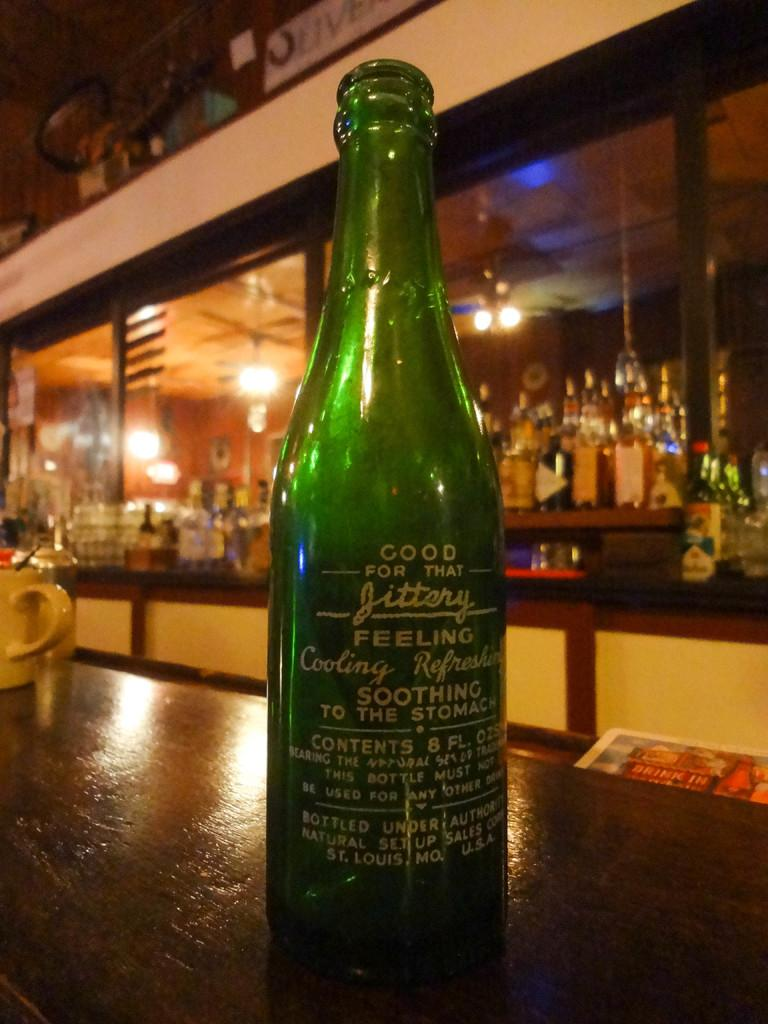What is the main object in the middle of the image? There is a bottle in the middle of the image. What is located on the left side of the image? There is a cup on the left side of the image. What type of furniture can be seen behind the bottle? There is a bar unit behind the bottle. What can be seen illuminating the background of the image? There are lights visible at the backside of the image. What book is the person reading in the image? There is no person or book visible in the image. How does the person swim in the image? There is no person or swimming activity depicted in the image. 